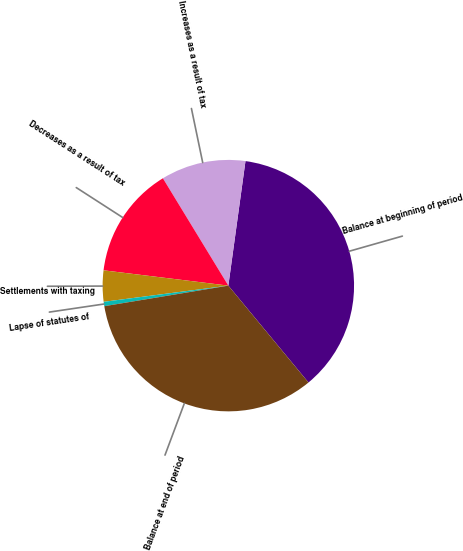Convert chart to OTSL. <chart><loc_0><loc_0><loc_500><loc_500><pie_chart><fcel>Balance at beginning of period<fcel>Increases as a result of tax<fcel>Decreases as a result of tax<fcel>Settlements with taxing<fcel>Lapse of statutes of<fcel>Balance at end of period<nl><fcel>36.82%<fcel>10.89%<fcel>14.34%<fcel>4.0%<fcel>0.56%<fcel>33.38%<nl></chart> 